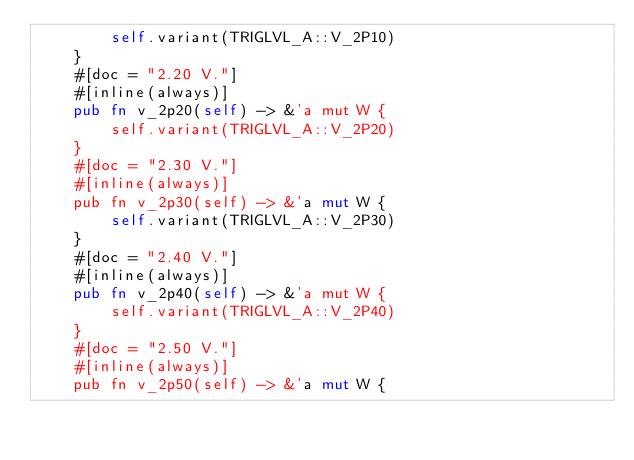<code> <loc_0><loc_0><loc_500><loc_500><_Rust_>        self.variant(TRIGLVL_A::V_2P10)
    }
    #[doc = "2.20 V."]
    #[inline(always)]
    pub fn v_2p20(self) -> &'a mut W {
        self.variant(TRIGLVL_A::V_2P20)
    }
    #[doc = "2.30 V."]
    #[inline(always)]
    pub fn v_2p30(self) -> &'a mut W {
        self.variant(TRIGLVL_A::V_2P30)
    }
    #[doc = "2.40 V."]
    #[inline(always)]
    pub fn v_2p40(self) -> &'a mut W {
        self.variant(TRIGLVL_A::V_2P40)
    }
    #[doc = "2.50 V."]
    #[inline(always)]
    pub fn v_2p50(self) -> &'a mut W {</code> 